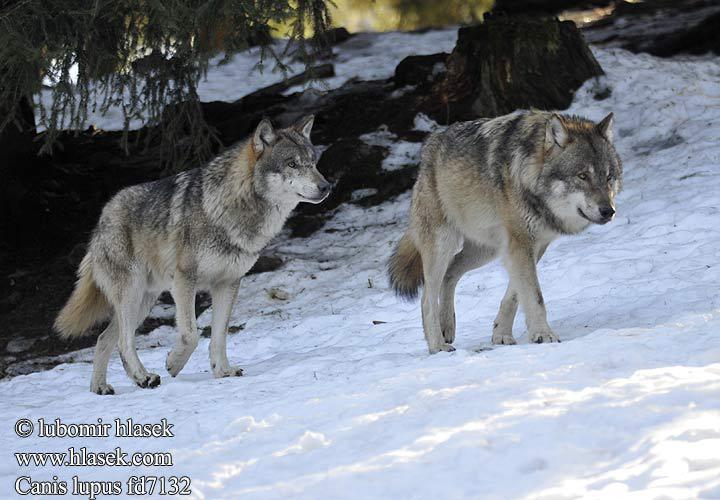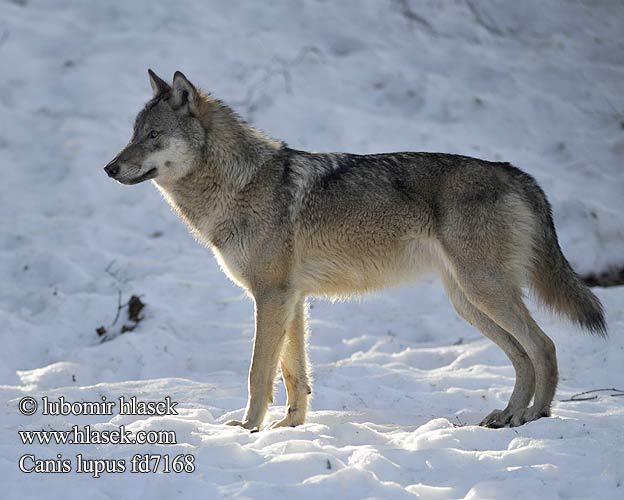The first image is the image on the left, the second image is the image on the right. Given the left and right images, does the statement "In each image the terrain around the wolf is covered in snow." hold true? Answer yes or no. Yes. The first image is the image on the left, the second image is the image on the right. Given the left and right images, does the statement "Each image contains a single wolf, and the left image features a wolf reclining on the snow with its body angled rightward." hold true? Answer yes or no. No. 